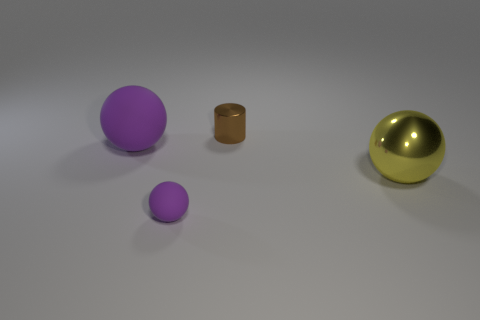Add 3 matte objects. How many objects exist? 7 Subtract all cylinders. How many objects are left? 3 Add 2 purple things. How many purple things exist? 4 Subtract 0 gray cylinders. How many objects are left? 4 Subtract all big things. Subtract all small brown metallic objects. How many objects are left? 1 Add 3 big purple balls. How many big purple balls are left? 4 